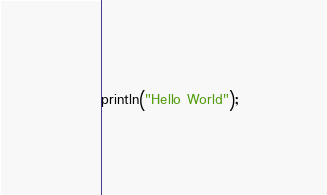<code> <loc_0><loc_0><loc_500><loc_500><_Kotlin_>println("Hello World");</code> 